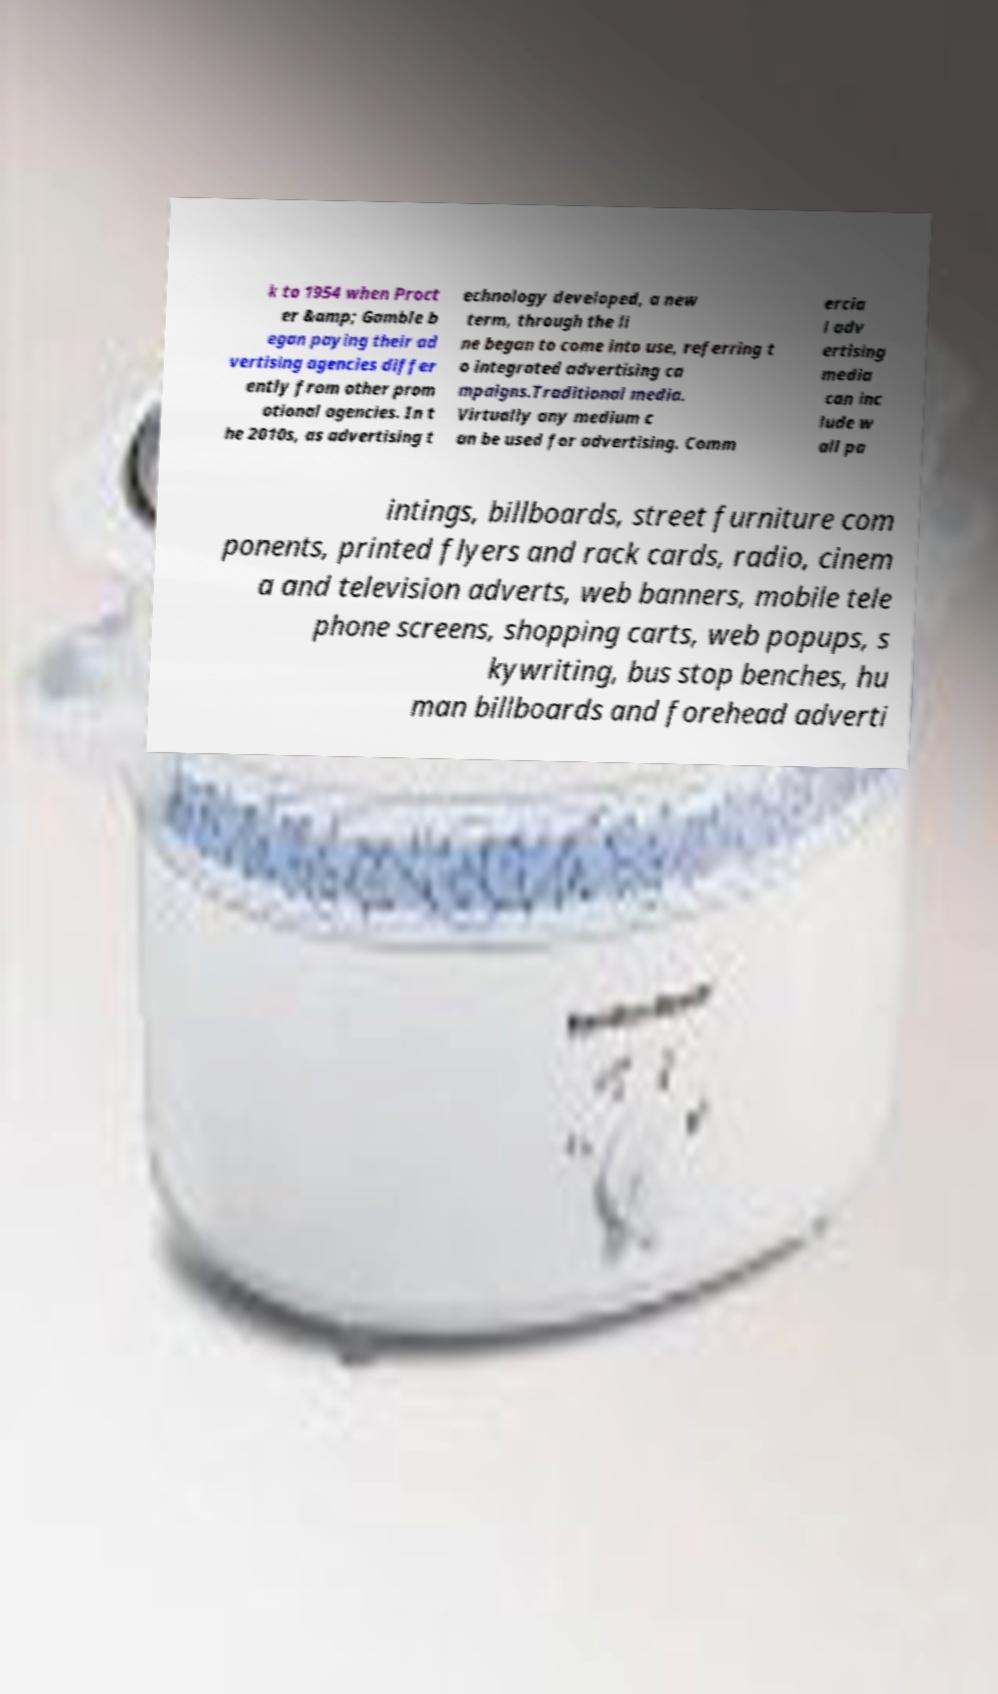What messages or text are displayed in this image? I need them in a readable, typed format. k to 1954 when Proct er &amp; Gamble b egan paying their ad vertising agencies differ ently from other prom otional agencies. In t he 2010s, as advertising t echnology developed, a new term, through the li ne began to come into use, referring t o integrated advertising ca mpaigns.Traditional media. Virtually any medium c an be used for advertising. Comm ercia l adv ertising media can inc lude w all pa intings, billboards, street furniture com ponents, printed flyers and rack cards, radio, cinem a and television adverts, web banners, mobile tele phone screens, shopping carts, web popups, s kywriting, bus stop benches, hu man billboards and forehead adverti 